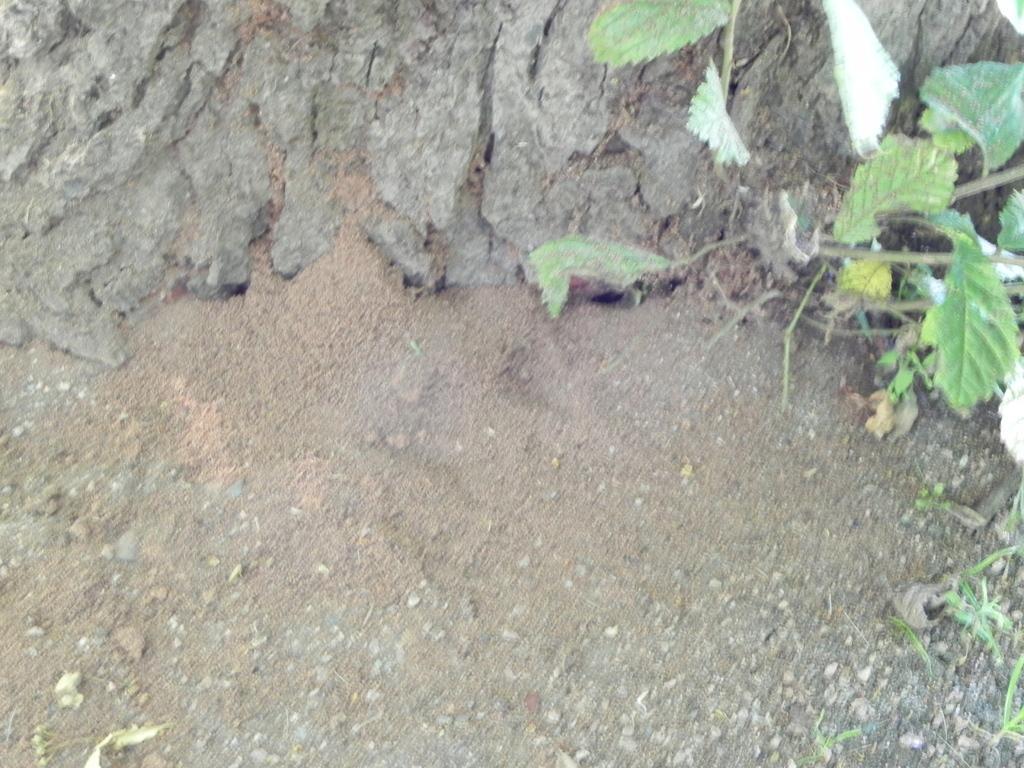Describe this image in one or two sentences. This picture is taken from outside of the city. In this image, in the right corner, we can see a plant with green leaves. In the background, we can see land with some stones. 